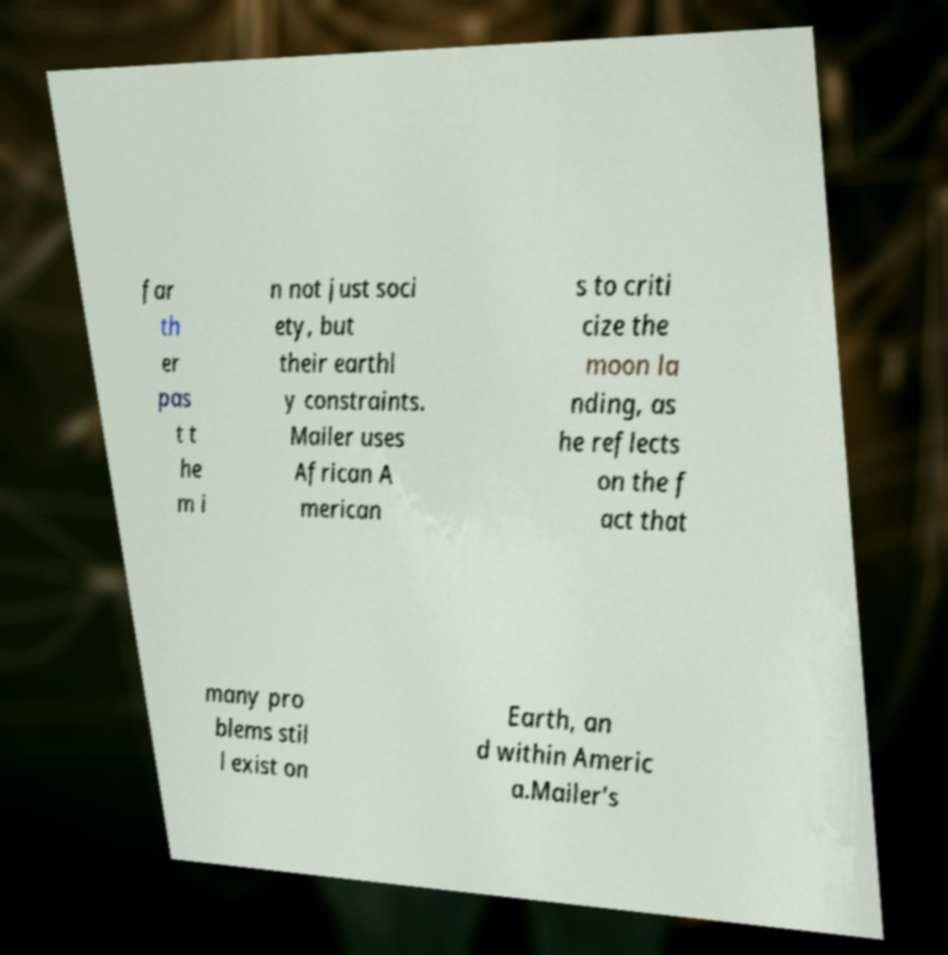Please read and relay the text visible in this image. What does it say? far th er pas t t he m i n not just soci ety, but their earthl y constraints. Mailer uses African A merican s to criti cize the moon la nding, as he reflects on the f act that many pro blems stil l exist on Earth, an d within Americ a.Mailer's 